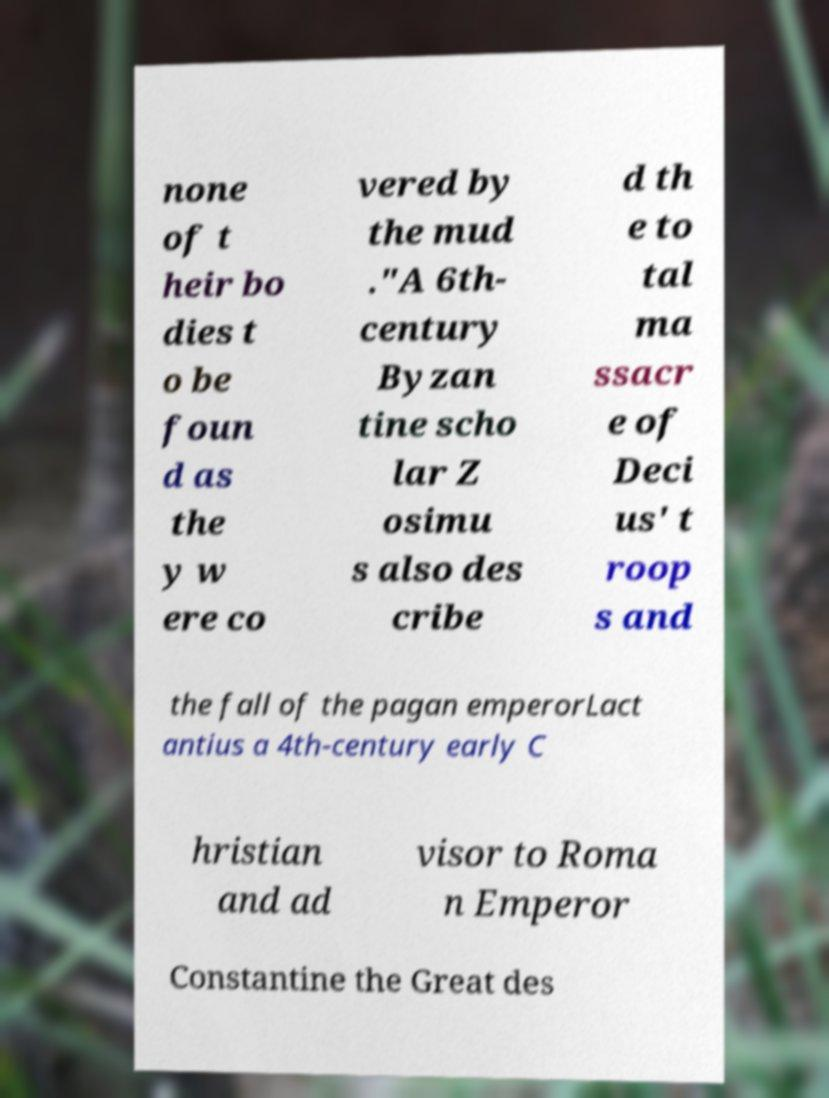For documentation purposes, I need the text within this image transcribed. Could you provide that? none of t heir bo dies t o be foun d as the y w ere co vered by the mud ."A 6th- century Byzan tine scho lar Z osimu s also des cribe d th e to tal ma ssacr e of Deci us' t roop s and the fall of the pagan emperorLact antius a 4th-century early C hristian and ad visor to Roma n Emperor Constantine the Great des 